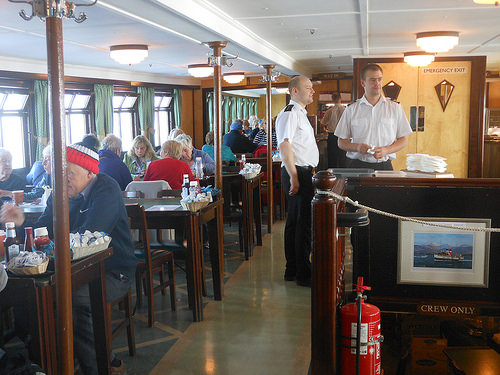<image>
Can you confirm if the man is behind the officer? No. The man is not behind the officer. From this viewpoint, the man appears to be positioned elsewhere in the scene. 